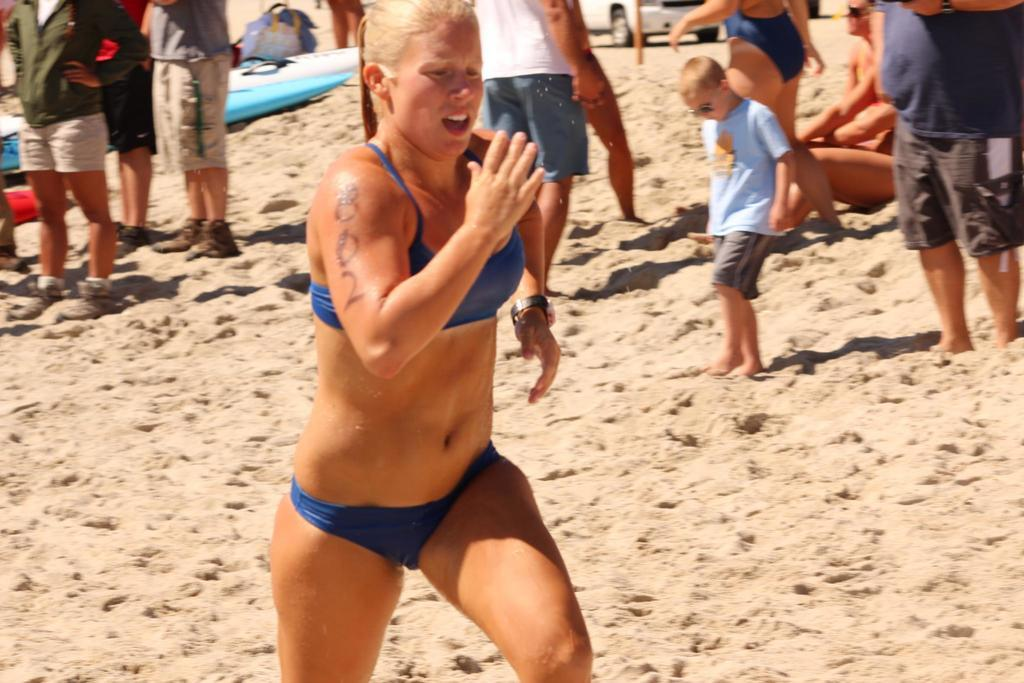What is the lady in the image doing? The lady is running in the image. Where is the lady running? The lady is running on a beach. What can be seen in the background of the image? There are people standing and sitting in the background of the image, as well as objects. What type of reaction can be seen on the paper in the image? There is no paper present in the image, so it is not possible to determine if there is any reaction on it. 